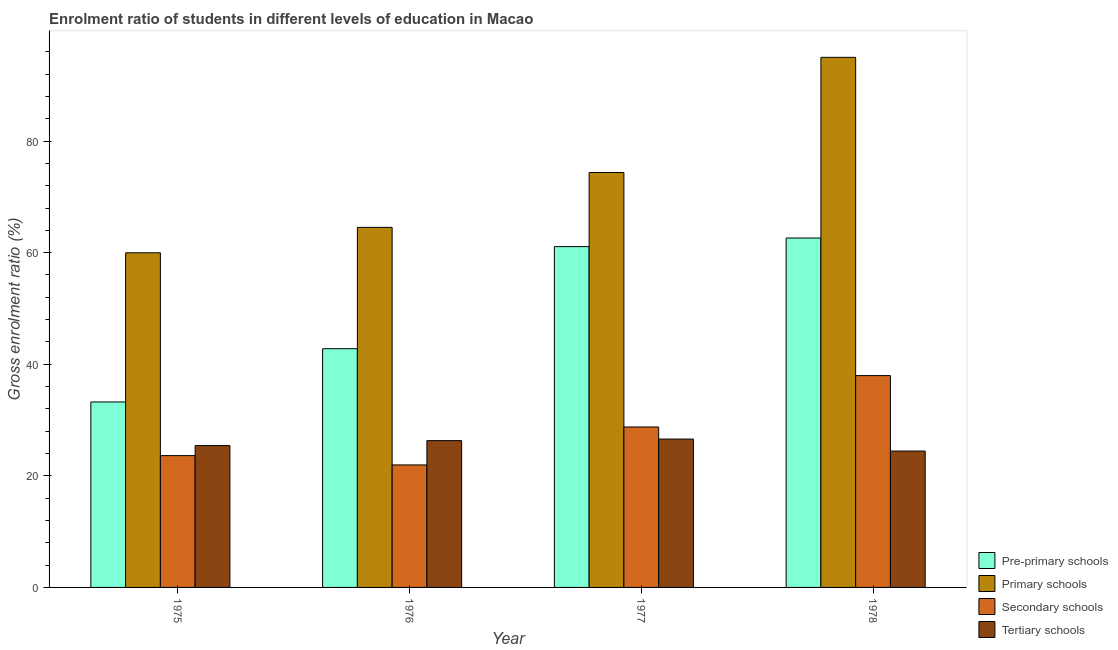How many bars are there on the 1st tick from the left?
Keep it short and to the point. 4. What is the label of the 2nd group of bars from the left?
Give a very brief answer. 1976. In how many cases, is the number of bars for a given year not equal to the number of legend labels?
Ensure brevity in your answer.  0. What is the gross enrolment ratio in tertiary schools in 1978?
Ensure brevity in your answer.  24.44. Across all years, what is the maximum gross enrolment ratio in tertiary schools?
Offer a terse response. 26.59. Across all years, what is the minimum gross enrolment ratio in pre-primary schools?
Give a very brief answer. 33.24. In which year was the gross enrolment ratio in tertiary schools minimum?
Offer a terse response. 1978. What is the total gross enrolment ratio in secondary schools in the graph?
Make the answer very short. 112.29. What is the difference between the gross enrolment ratio in secondary schools in 1977 and that in 1978?
Provide a short and direct response. -9.21. What is the difference between the gross enrolment ratio in secondary schools in 1976 and the gross enrolment ratio in pre-primary schools in 1977?
Offer a terse response. -6.8. What is the average gross enrolment ratio in primary schools per year?
Provide a succinct answer. 73.47. In the year 1976, what is the difference between the gross enrolment ratio in secondary schools and gross enrolment ratio in pre-primary schools?
Ensure brevity in your answer.  0. In how many years, is the gross enrolment ratio in secondary schools greater than 16 %?
Keep it short and to the point. 4. What is the ratio of the gross enrolment ratio in tertiary schools in 1975 to that in 1977?
Your answer should be compact. 0.96. Is the gross enrolment ratio in tertiary schools in 1975 less than that in 1978?
Provide a succinct answer. No. Is the difference between the gross enrolment ratio in secondary schools in 1977 and 1978 greater than the difference between the gross enrolment ratio in tertiary schools in 1977 and 1978?
Offer a very short reply. No. What is the difference between the highest and the second highest gross enrolment ratio in secondary schools?
Offer a terse response. 9.21. What is the difference between the highest and the lowest gross enrolment ratio in primary schools?
Offer a terse response. 35.03. In how many years, is the gross enrolment ratio in pre-primary schools greater than the average gross enrolment ratio in pre-primary schools taken over all years?
Make the answer very short. 2. What does the 1st bar from the left in 1978 represents?
Your response must be concise. Pre-primary schools. What does the 2nd bar from the right in 1978 represents?
Offer a very short reply. Secondary schools. What is the difference between two consecutive major ticks on the Y-axis?
Make the answer very short. 20. Are the values on the major ticks of Y-axis written in scientific E-notation?
Keep it short and to the point. No. Does the graph contain any zero values?
Offer a terse response. No. Does the graph contain grids?
Offer a terse response. No. Where does the legend appear in the graph?
Your response must be concise. Bottom right. What is the title of the graph?
Provide a short and direct response. Enrolment ratio of students in different levels of education in Macao. What is the Gross enrolment ratio (%) of Pre-primary schools in 1975?
Your response must be concise. 33.24. What is the Gross enrolment ratio (%) in Primary schools in 1975?
Provide a succinct answer. 59.97. What is the Gross enrolment ratio (%) in Secondary schools in 1975?
Your answer should be very brief. 23.62. What is the Gross enrolment ratio (%) in Tertiary schools in 1975?
Give a very brief answer. 25.42. What is the Gross enrolment ratio (%) of Pre-primary schools in 1976?
Your answer should be very brief. 42.78. What is the Gross enrolment ratio (%) in Primary schools in 1976?
Ensure brevity in your answer.  64.53. What is the Gross enrolment ratio (%) in Secondary schools in 1976?
Offer a terse response. 21.95. What is the Gross enrolment ratio (%) in Tertiary schools in 1976?
Make the answer very short. 26.31. What is the Gross enrolment ratio (%) in Pre-primary schools in 1977?
Your answer should be very brief. 61.08. What is the Gross enrolment ratio (%) in Primary schools in 1977?
Give a very brief answer. 74.36. What is the Gross enrolment ratio (%) in Secondary schools in 1977?
Your answer should be very brief. 28.76. What is the Gross enrolment ratio (%) of Tertiary schools in 1977?
Your answer should be very brief. 26.59. What is the Gross enrolment ratio (%) in Pre-primary schools in 1978?
Your response must be concise. 62.62. What is the Gross enrolment ratio (%) in Primary schools in 1978?
Offer a terse response. 95. What is the Gross enrolment ratio (%) of Secondary schools in 1978?
Your response must be concise. 37.96. What is the Gross enrolment ratio (%) of Tertiary schools in 1978?
Keep it short and to the point. 24.44. Across all years, what is the maximum Gross enrolment ratio (%) in Pre-primary schools?
Provide a succinct answer. 62.62. Across all years, what is the maximum Gross enrolment ratio (%) in Primary schools?
Your answer should be very brief. 95. Across all years, what is the maximum Gross enrolment ratio (%) in Secondary schools?
Ensure brevity in your answer.  37.96. Across all years, what is the maximum Gross enrolment ratio (%) of Tertiary schools?
Make the answer very short. 26.59. Across all years, what is the minimum Gross enrolment ratio (%) of Pre-primary schools?
Offer a terse response. 33.24. Across all years, what is the minimum Gross enrolment ratio (%) of Primary schools?
Keep it short and to the point. 59.97. Across all years, what is the minimum Gross enrolment ratio (%) in Secondary schools?
Give a very brief answer. 21.95. Across all years, what is the minimum Gross enrolment ratio (%) in Tertiary schools?
Ensure brevity in your answer.  24.44. What is the total Gross enrolment ratio (%) in Pre-primary schools in the graph?
Keep it short and to the point. 199.72. What is the total Gross enrolment ratio (%) of Primary schools in the graph?
Your answer should be compact. 293.87. What is the total Gross enrolment ratio (%) in Secondary schools in the graph?
Offer a very short reply. 112.29. What is the total Gross enrolment ratio (%) in Tertiary schools in the graph?
Ensure brevity in your answer.  102.76. What is the difference between the Gross enrolment ratio (%) in Pre-primary schools in 1975 and that in 1976?
Offer a terse response. -9.54. What is the difference between the Gross enrolment ratio (%) in Primary schools in 1975 and that in 1976?
Offer a terse response. -4.56. What is the difference between the Gross enrolment ratio (%) in Secondary schools in 1975 and that in 1976?
Provide a short and direct response. 1.67. What is the difference between the Gross enrolment ratio (%) in Tertiary schools in 1975 and that in 1976?
Provide a short and direct response. -0.89. What is the difference between the Gross enrolment ratio (%) in Pre-primary schools in 1975 and that in 1977?
Ensure brevity in your answer.  -27.84. What is the difference between the Gross enrolment ratio (%) of Primary schools in 1975 and that in 1977?
Offer a very short reply. -14.39. What is the difference between the Gross enrolment ratio (%) of Secondary schools in 1975 and that in 1977?
Provide a short and direct response. -5.13. What is the difference between the Gross enrolment ratio (%) in Tertiary schools in 1975 and that in 1977?
Offer a terse response. -1.17. What is the difference between the Gross enrolment ratio (%) of Pre-primary schools in 1975 and that in 1978?
Provide a short and direct response. -29.38. What is the difference between the Gross enrolment ratio (%) in Primary schools in 1975 and that in 1978?
Provide a short and direct response. -35.03. What is the difference between the Gross enrolment ratio (%) of Secondary schools in 1975 and that in 1978?
Make the answer very short. -14.34. What is the difference between the Gross enrolment ratio (%) in Tertiary schools in 1975 and that in 1978?
Give a very brief answer. 0.98. What is the difference between the Gross enrolment ratio (%) in Pre-primary schools in 1976 and that in 1977?
Provide a short and direct response. -18.3. What is the difference between the Gross enrolment ratio (%) in Primary schools in 1976 and that in 1977?
Your answer should be very brief. -9.83. What is the difference between the Gross enrolment ratio (%) in Secondary schools in 1976 and that in 1977?
Your answer should be compact. -6.8. What is the difference between the Gross enrolment ratio (%) in Tertiary schools in 1976 and that in 1977?
Provide a short and direct response. -0.28. What is the difference between the Gross enrolment ratio (%) in Pre-primary schools in 1976 and that in 1978?
Your answer should be compact. -19.84. What is the difference between the Gross enrolment ratio (%) in Primary schools in 1976 and that in 1978?
Your answer should be compact. -30.47. What is the difference between the Gross enrolment ratio (%) of Secondary schools in 1976 and that in 1978?
Your answer should be compact. -16.01. What is the difference between the Gross enrolment ratio (%) of Tertiary schools in 1976 and that in 1978?
Give a very brief answer. 1.87. What is the difference between the Gross enrolment ratio (%) of Pre-primary schools in 1977 and that in 1978?
Keep it short and to the point. -1.54. What is the difference between the Gross enrolment ratio (%) in Primary schools in 1977 and that in 1978?
Ensure brevity in your answer.  -20.64. What is the difference between the Gross enrolment ratio (%) of Secondary schools in 1977 and that in 1978?
Provide a short and direct response. -9.21. What is the difference between the Gross enrolment ratio (%) in Tertiary schools in 1977 and that in 1978?
Provide a succinct answer. 2.15. What is the difference between the Gross enrolment ratio (%) in Pre-primary schools in 1975 and the Gross enrolment ratio (%) in Primary schools in 1976?
Your answer should be compact. -31.29. What is the difference between the Gross enrolment ratio (%) of Pre-primary schools in 1975 and the Gross enrolment ratio (%) of Secondary schools in 1976?
Your answer should be compact. 11.29. What is the difference between the Gross enrolment ratio (%) in Pre-primary schools in 1975 and the Gross enrolment ratio (%) in Tertiary schools in 1976?
Offer a terse response. 6.93. What is the difference between the Gross enrolment ratio (%) of Primary schools in 1975 and the Gross enrolment ratio (%) of Secondary schools in 1976?
Offer a very short reply. 38.02. What is the difference between the Gross enrolment ratio (%) in Primary schools in 1975 and the Gross enrolment ratio (%) in Tertiary schools in 1976?
Your answer should be very brief. 33.67. What is the difference between the Gross enrolment ratio (%) in Secondary schools in 1975 and the Gross enrolment ratio (%) in Tertiary schools in 1976?
Ensure brevity in your answer.  -2.69. What is the difference between the Gross enrolment ratio (%) of Pre-primary schools in 1975 and the Gross enrolment ratio (%) of Primary schools in 1977?
Offer a terse response. -41.12. What is the difference between the Gross enrolment ratio (%) of Pre-primary schools in 1975 and the Gross enrolment ratio (%) of Secondary schools in 1977?
Provide a succinct answer. 4.48. What is the difference between the Gross enrolment ratio (%) of Pre-primary schools in 1975 and the Gross enrolment ratio (%) of Tertiary schools in 1977?
Your answer should be compact. 6.65. What is the difference between the Gross enrolment ratio (%) in Primary schools in 1975 and the Gross enrolment ratio (%) in Secondary schools in 1977?
Give a very brief answer. 31.22. What is the difference between the Gross enrolment ratio (%) in Primary schools in 1975 and the Gross enrolment ratio (%) in Tertiary schools in 1977?
Provide a short and direct response. 33.38. What is the difference between the Gross enrolment ratio (%) in Secondary schools in 1975 and the Gross enrolment ratio (%) in Tertiary schools in 1977?
Keep it short and to the point. -2.97. What is the difference between the Gross enrolment ratio (%) in Pre-primary schools in 1975 and the Gross enrolment ratio (%) in Primary schools in 1978?
Keep it short and to the point. -61.76. What is the difference between the Gross enrolment ratio (%) of Pre-primary schools in 1975 and the Gross enrolment ratio (%) of Secondary schools in 1978?
Provide a short and direct response. -4.73. What is the difference between the Gross enrolment ratio (%) of Pre-primary schools in 1975 and the Gross enrolment ratio (%) of Tertiary schools in 1978?
Make the answer very short. 8.8. What is the difference between the Gross enrolment ratio (%) of Primary schools in 1975 and the Gross enrolment ratio (%) of Secondary schools in 1978?
Offer a terse response. 22.01. What is the difference between the Gross enrolment ratio (%) in Primary schools in 1975 and the Gross enrolment ratio (%) in Tertiary schools in 1978?
Provide a succinct answer. 35.53. What is the difference between the Gross enrolment ratio (%) of Secondary schools in 1975 and the Gross enrolment ratio (%) of Tertiary schools in 1978?
Give a very brief answer. -0.82. What is the difference between the Gross enrolment ratio (%) of Pre-primary schools in 1976 and the Gross enrolment ratio (%) of Primary schools in 1977?
Give a very brief answer. -31.58. What is the difference between the Gross enrolment ratio (%) in Pre-primary schools in 1976 and the Gross enrolment ratio (%) in Secondary schools in 1977?
Give a very brief answer. 14.03. What is the difference between the Gross enrolment ratio (%) of Pre-primary schools in 1976 and the Gross enrolment ratio (%) of Tertiary schools in 1977?
Keep it short and to the point. 16.19. What is the difference between the Gross enrolment ratio (%) of Primary schools in 1976 and the Gross enrolment ratio (%) of Secondary schools in 1977?
Make the answer very short. 35.77. What is the difference between the Gross enrolment ratio (%) of Primary schools in 1976 and the Gross enrolment ratio (%) of Tertiary schools in 1977?
Keep it short and to the point. 37.94. What is the difference between the Gross enrolment ratio (%) in Secondary schools in 1976 and the Gross enrolment ratio (%) in Tertiary schools in 1977?
Your answer should be very brief. -4.64. What is the difference between the Gross enrolment ratio (%) of Pre-primary schools in 1976 and the Gross enrolment ratio (%) of Primary schools in 1978?
Your response must be concise. -52.22. What is the difference between the Gross enrolment ratio (%) of Pre-primary schools in 1976 and the Gross enrolment ratio (%) of Secondary schools in 1978?
Offer a very short reply. 4.82. What is the difference between the Gross enrolment ratio (%) in Pre-primary schools in 1976 and the Gross enrolment ratio (%) in Tertiary schools in 1978?
Make the answer very short. 18.34. What is the difference between the Gross enrolment ratio (%) in Primary schools in 1976 and the Gross enrolment ratio (%) in Secondary schools in 1978?
Offer a very short reply. 26.57. What is the difference between the Gross enrolment ratio (%) in Primary schools in 1976 and the Gross enrolment ratio (%) in Tertiary schools in 1978?
Make the answer very short. 40.09. What is the difference between the Gross enrolment ratio (%) in Secondary schools in 1976 and the Gross enrolment ratio (%) in Tertiary schools in 1978?
Your response must be concise. -2.49. What is the difference between the Gross enrolment ratio (%) of Pre-primary schools in 1977 and the Gross enrolment ratio (%) of Primary schools in 1978?
Give a very brief answer. -33.92. What is the difference between the Gross enrolment ratio (%) of Pre-primary schools in 1977 and the Gross enrolment ratio (%) of Secondary schools in 1978?
Keep it short and to the point. 23.12. What is the difference between the Gross enrolment ratio (%) in Pre-primary schools in 1977 and the Gross enrolment ratio (%) in Tertiary schools in 1978?
Offer a very short reply. 36.64. What is the difference between the Gross enrolment ratio (%) of Primary schools in 1977 and the Gross enrolment ratio (%) of Secondary schools in 1978?
Your answer should be very brief. 36.39. What is the difference between the Gross enrolment ratio (%) of Primary schools in 1977 and the Gross enrolment ratio (%) of Tertiary schools in 1978?
Your answer should be compact. 49.92. What is the difference between the Gross enrolment ratio (%) of Secondary schools in 1977 and the Gross enrolment ratio (%) of Tertiary schools in 1978?
Your answer should be very brief. 4.32. What is the average Gross enrolment ratio (%) in Pre-primary schools per year?
Provide a short and direct response. 49.93. What is the average Gross enrolment ratio (%) of Primary schools per year?
Make the answer very short. 73.47. What is the average Gross enrolment ratio (%) of Secondary schools per year?
Your answer should be compact. 28.07. What is the average Gross enrolment ratio (%) in Tertiary schools per year?
Your answer should be compact. 25.69. In the year 1975, what is the difference between the Gross enrolment ratio (%) of Pre-primary schools and Gross enrolment ratio (%) of Primary schools?
Your response must be concise. -26.73. In the year 1975, what is the difference between the Gross enrolment ratio (%) of Pre-primary schools and Gross enrolment ratio (%) of Secondary schools?
Ensure brevity in your answer.  9.62. In the year 1975, what is the difference between the Gross enrolment ratio (%) of Pre-primary schools and Gross enrolment ratio (%) of Tertiary schools?
Your response must be concise. 7.82. In the year 1975, what is the difference between the Gross enrolment ratio (%) in Primary schools and Gross enrolment ratio (%) in Secondary schools?
Make the answer very short. 36.35. In the year 1975, what is the difference between the Gross enrolment ratio (%) in Primary schools and Gross enrolment ratio (%) in Tertiary schools?
Your answer should be compact. 34.55. In the year 1975, what is the difference between the Gross enrolment ratio (%) of Secondary schools and Gross enrolment ratio (%) of Tertiary schools?
Provide a short and direct response. -1.8. In the year 1976, what is the difference between the Gross enrolment ratio (%) of Pre-primary schools and Gross enrolment ratio (%) of Primary schools?
Your answer should be compact. -21.75. In the year 1976, what is the difference between the Gross enrolment ratio (%) of Pre-primary schools and Gross enrolment ratio (%) of Secondary schools?
Provide a short and direct response. 20.83. In the year 1976, what is the difference between the Gross enrolment ratio (%) in Pre-primary schools and Gross enrolment ratio (%) in Tertiary schools?
Your response must be concise. 16.48. In the year 1976, what is the difference between the Gross enrolment ratio (%) in Primary schools and Gross enrolment ratio (%) in Secondary schools?
Offer a very short reply. 42.58. In the year 1976, what is the difference between the Gross enrolment ratio (%) in Primary schools and Gross enrolment ratio (%) in Tertiary schools?
Offer a very short reply. 38.22. In the year 1976, what is the difference between the Gross enrolment ratio (%) in Secondary schools and Gross enrolment ratio (%) in Tertiary schools?
Your answer should be very brief. -4.35. In the year 1977, what is the difference between the Gross enrolment ratio (%) in Pre-primary schools and Gross enrolment ratio (%) in Primary schools?
Give a very brief answer. -13.28. In the year 1977, what is the difference between the Gross enrolment ratio (%) in Pre-primary schools and Gross enrolment ratio (%) in Secondary schools?
Give a very brief answer. 32.32. In the year 1977, what is the difference between the Gross enrolment ratio (%) of Pre-primary schools and Gross enrolment ratio (%) of Tertiary schools?
Keep it short and to the point. 34.49. In the year 1977, what is the difference between the Gross enrolment ratio (%) of Primary schools and Gross enrolment ratio (%) of Secondary schools?
Offer a terse response. 45.6. In the year 1977, what is the difference between the Gross enrolment ratio (%) of Primary schools and Gross enrolment ratio (%) of Tertiary schools?
Give a very brief answer. 47.77. In the year 1977, what is the difference between the Gross enrolment ratio (%) in Secondary schools and Gross enrolment ratio (%) in Tertiary schools?
Your answer should be compact. 2.17. In the year 1978, what is the difference between the Gross enrolment ratio (%) in Pre-primary schools and Gross enrolment ratio (%) in Primary schools?
Your answer should be very brief. -32.38. In the year 1978, what is the difference between the Gross enrolment ratio (%) of Pre-primary schools and Gross enrolment ratio (%) of Secondary schools?
Provide a succinct answer. 24.66. In the year 1978, what is the difference between the Gross enrolment ratio (%) of Pre-primary schools and Gross enrolment ratio (%) of Tertiary schools?
Keep it short and to the point. 38.18. In the year 1978, what is the difference between the Gross enrolment ratio (%) of Primary schools and Gross enrolment ratio (%) of Secondary schools?
Your answer should be very brief. 57.04. In the year 1978, what is the difference between the Gross enrolment ratio (%) of Primary schools and Gross enrolment ratio (%) of Tertiary schools?
Your response must be concise. 70.56. In the year 1978, what is the difference between the Gross enrolment ratio (%) in Secondary schools and Gross enrolment ratio (%) in Tertiary schools?
Make the answer very short. 13.53. What is the ratio of the Gross enrolment ratio (%) in Pre-primary schools in 1975 to that in 1976?
Make the answer very short. 0.78. What is the ratio of the Gross enrolment ratio (%) in Primary schools in 1975 to that in 1976?
Provide a short and direct response. 0.93. What is the ratio of the Gross enrolment ratio (%) in Secondary schools in 1975 to that in 1976?
Provide a short and direct response. 1.08. What is the ratio of the Gross enrolment ratio (%) in Tertiary schools in 1975 to that in 1976?
Keep it short and to the point. 0.97. What is the ratio of the Gross enrolment ratio (%) in Pre-primary schools in 1975 to that in 1977?
Keep it short and to the point. 0.54. What is the ratio of the Gross enrolment ratio (%) in Primary schools in 1975 to that in 1977?
Provide a succinct answer. 0.81. What is the ratio of the Gross enrolment ratio (%) in Secondary schools in 1975 to that in 1977?
Your answer should be compact. 0.82. What is the ratio of the Gross enrolment ratio (%) of Tertiary schools in 1975 to that in 1977?
Make the answer very short. 0.96. What is the ratio of the Gross enrolment ratio (%) of Pre-primary schools in 1975 to that in 1978?
Offer a very short reply. 0.53. What is the ratio of the Gross enrolment ratio (%) of Primary schools in 1975 to that in 1978?
Keep it short and to the point. 0.63. What is the ratio of the Gross enrolment ratio (%) of Secondary schools in 1975 to that in 1978?
Ensure brevity in your answer.  0.62. What is the ratio of the Gross enrolment ratio (%) of Tertiary schools in 1975 to that in 1978?
Provide a short and direct response. 1.04. What is the ratio of the Gross enrolment ratio (%) of Pre-primary schools in 1976 to that in 1977?
Ensure brevity in your answer.  0.7. What is the ratio of the Gross enrolment ratio (%) of Primary schools in 1976 to that in 1977?
Make the answer very short. 0.87. What is the ratio of the Gross enrolment ratio (%) in Secondary schools in 1976 to that in 1977?
Your answer should be very brief. 0.76. What is the ratio of the Gross enrolment ratio (%) in Tertiary schools in 1976 to that in 1977?
Your answer should be compact. 0.99. What is the ratio of the Gross enrolment ratio (%) of Pre-primary schools in 1976 to that in 1978?
Your answer should be very brief. 0.68. What is the ratio of the Gross enrolment ratio (%) of Primary schools in 1976 to that in 1978?
Your answer should be very brief. 0.68. What is the ratio of the Gross enrolment ratio (%) in Secondary schools in 1976 to that in 1978?
Your response must be concise. 0.58. What is the ratio of the Gross enrolment ratio (%) in Tertiary schools in 1976 to that in 1978?
Offer a very short reply. 1.08. What is the ratio of the Gross enrolment ratio (%) in Pre-primary schools in 1977 to that in 1978?
Keep it short and to the point. 0.98. What is the ratio of the Gross enrolment ratio (%) in Primary schools in 1977 to that in 1978?
Your answer should be very brief. 0.78. What is the ratio of the Gross enrolment ratio (%) in Secondary schools in 1977 to that in 1978?
Your response must be concise. 0.76. What is the ratio of the Gross enrolment ratio (%) of Tertiary schools in 1977 to that in 1978?
Keep it short and to the point. 1.09. What is the difference between the highest and the second highest Gross enrolment ratio (%) of Pre-primary schools?
Keep it short and to the point. 1.54. What is the difference between the highest and the second highest Gross enrolment ratio (%) in Primary schools?
Offer a very short reply. 20.64. What is the difference between the highest and the second highest Gross enrolment ratio (%) of Secondary schools?
Keep it short and to the point. 9.21. What is the difference between the highest and the second highest Gross enrolment ratio (%) in Tertiary schools?
Your answer should be compact. 0.28. What is the difference between the highest and the lowest Gross enrolment ratio (%) in Pre-primary schools?
Provide a short and direct response. 29.38. What is the difference between the highest and the lowest Gross enrolment ratio (%) of Primary schools?
Offer a terse response. 35.03. What is the difference between the highest and the lowest Gross enrolment ratio (%) of Secondary schools?
Offer a terse response. 16.01. What is the difference between the highest and the lowest Gross enrolment ratio (%) in Tertiary schools?
Make the answer very short. 2.15. 